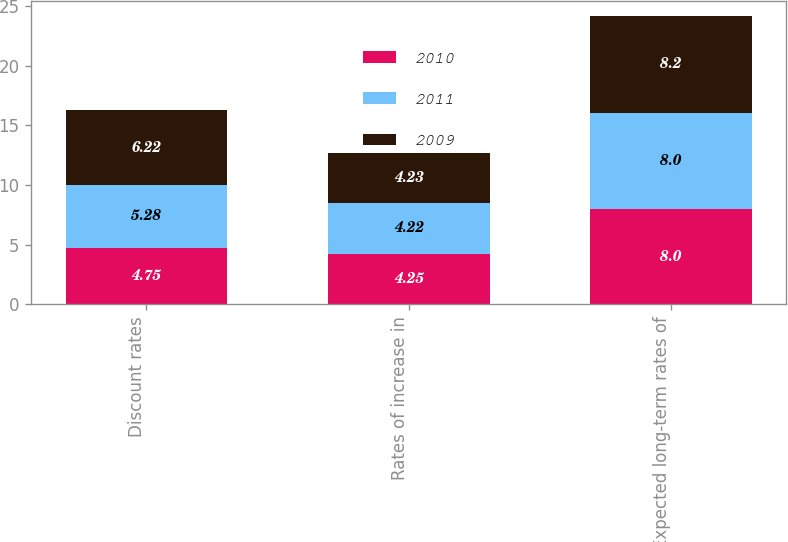<chart> <loc_0><loc_0><loc_500><loc_500><stacked_bar_chart><ecel><fcel>Discount rates<fcel>Rates of increase in<fcel>Expected long-term rates of<nl><fcel>2010<fcel>4.75<fcel>4.25<fcel>8<nl><fcel>2011<fcel>5.28<fcel>4.22<fcel>8<nl><fcel>2009<fcel>6.22<fcel>4.23<fcel>8.2<nl></chart> 